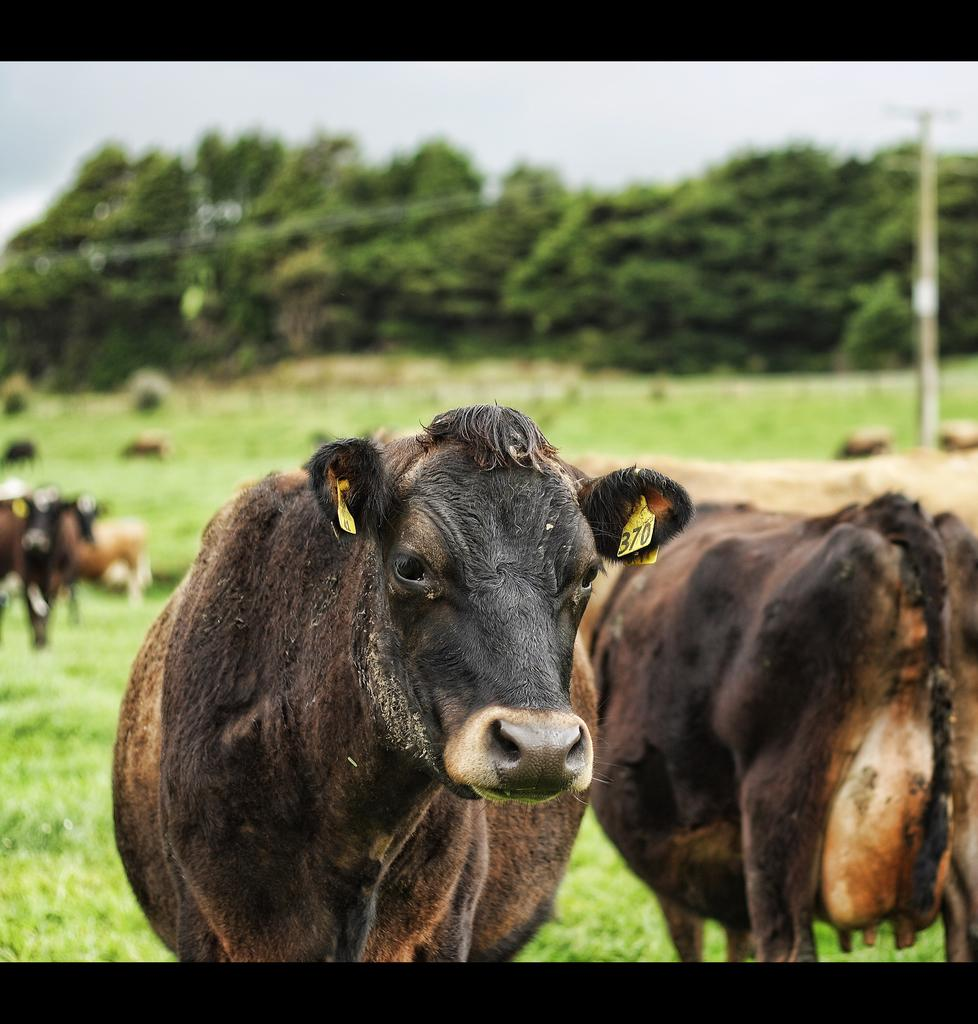What types of living organisms can be seen in the image? There are animals in the image. Where are the animals located in the image? The animals are at the bottom of the image. What can be seen in the background of the image? There is grass, trees, and the sky visible in the background of the image. What direction is the scarecrow facing in the image? There is no scarecrow present in the image. Can you tell me how many cracks are visible in the image? There are no cracks visible in the image. 